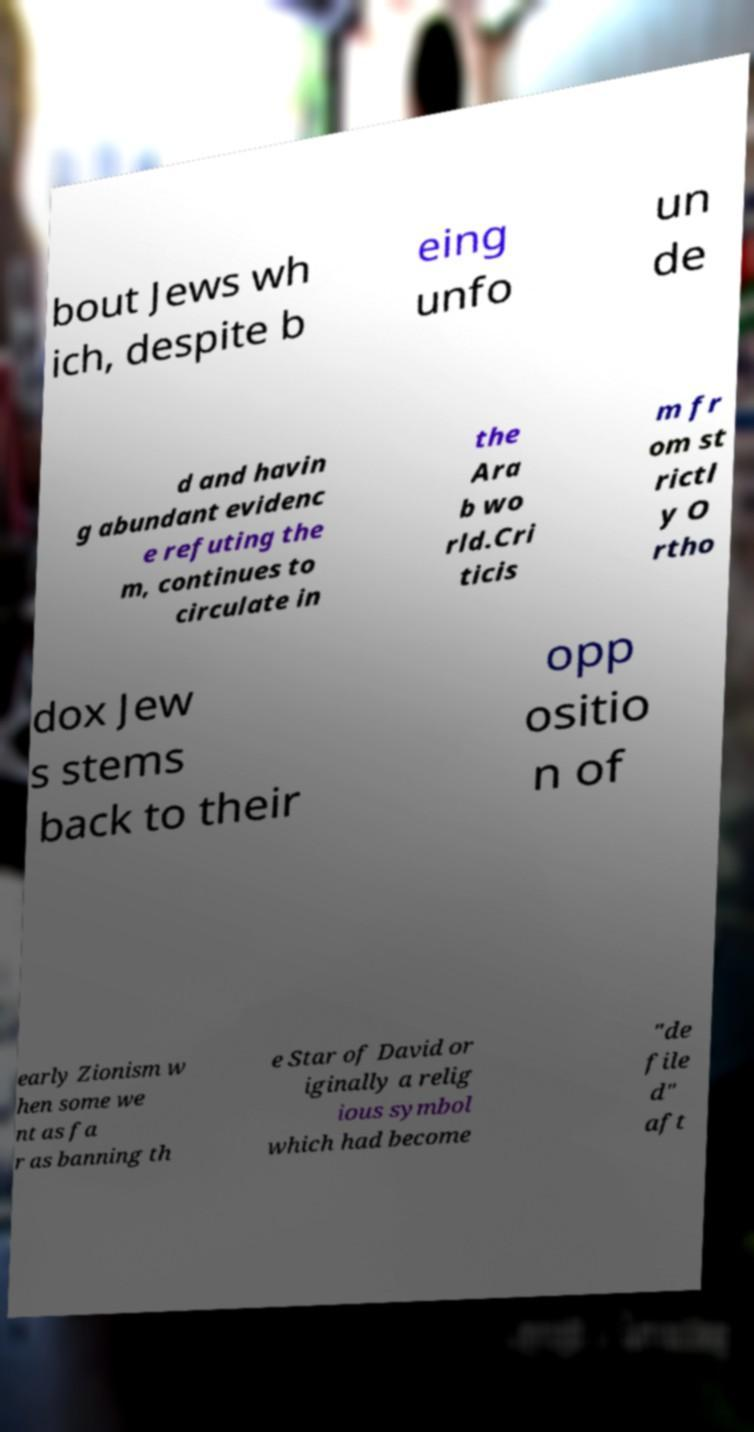For documentation purposes, I need the text within this image transcribed. Could you provide that? bout Jews wh ich, despite b eing unfo un de d and havin g abundant evidenc e refuting the m, continues to circulate in the Ara b wo rld.Cri ticis m fr om st rictl y O rtho dox Jew s stems back to their opp ositio n of early Zionism w hen some we nt as fa r as banning th e Star of David or iginally a relig ious symbol which had become "de file d" aft 